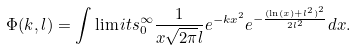<formula> <loc_0><loc_0><loc_500><loc_500>\Phi ( k , l ) = \int \lim i t s _ { 0 } ^ { \infty } { \frac { 1 } { { x \sqrt { 2 \pi } l } } } { e ^ { - k { x ^ { 2 } } } } { e ^ { - \frac { { { { ( \ln ( x ) + { l ^ { 2 } } ) } ^ { 2 } } } } { { 2 { l ^ { 2 } } } } } } d x .</formula> 